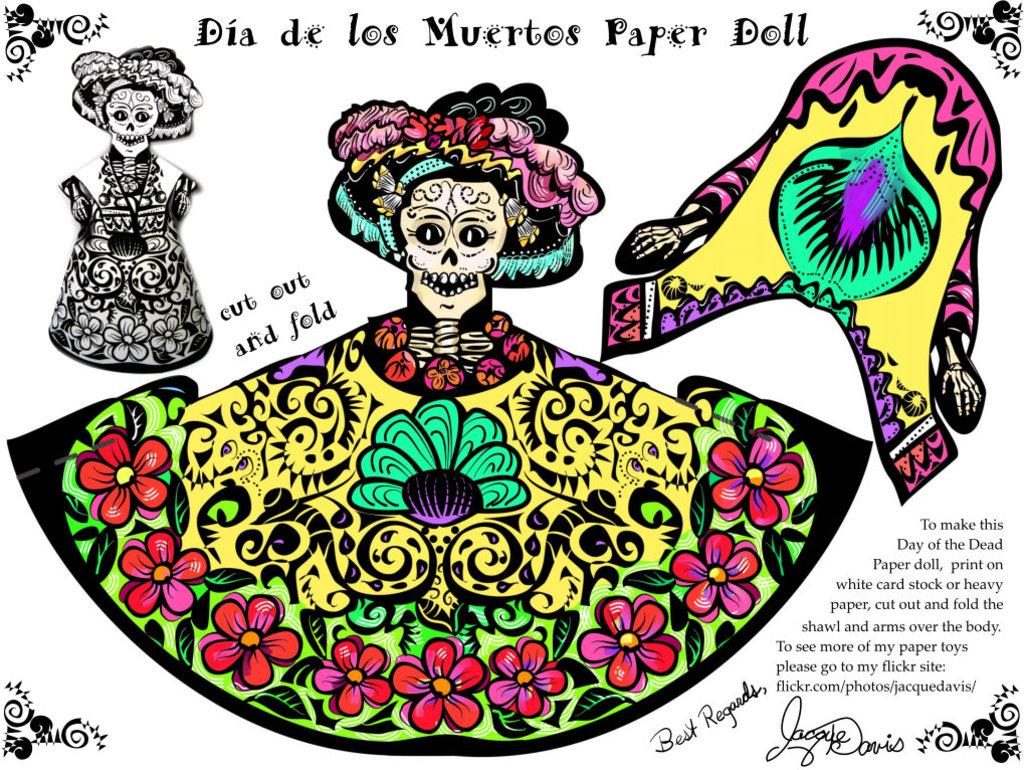What type of artwork is depicted in the image? The image is a painting. What objects can be seen in the painting? There are toys in the painting. Where can text be found in the painting? There is text at the bottom and top of the painting. How many kittens are sitting on the owl in the painting? There is no owl or kittens present in the painting; it features toys and text. 